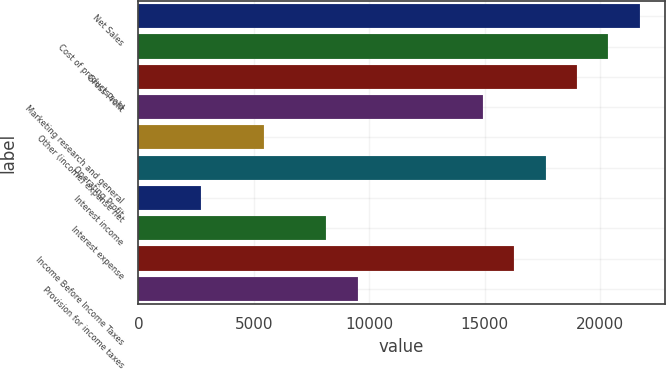<chart> <loc_0><loc_0><loc_500><loc_500><bar_chart><fcel>Net Sales<fcel>Cost of products sold<fcel>Gross Profit<fcel>Marketing research and general<fcel>Other (income) expense net<fcel>Operating Profit<fcel>Interest income<fcel>Interest expense<fcel>Income Before Income Taxes<fcel>Provision for income taxes<nl><fcel>21704.2<fcel>20347.9<fcel>18991.6<fcel>14922.6<fcel>5428.48<fcel>17635.3<fcel>2715.86<fcel>8141.1<fcel>16279<fcel>9497.41<nl></chart> 